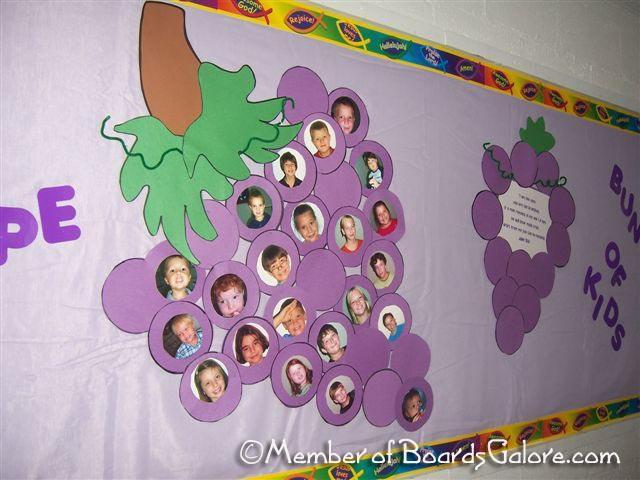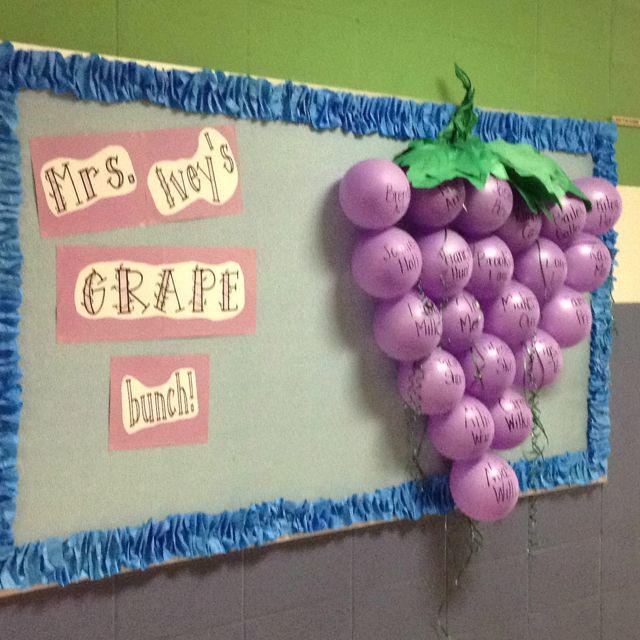The first image is the image on the left, the second image is the image on the right. Examine the images to the left and right. Is the description "The right image shows purple balloons used to represent grapes in a cluster, and the left image shows childrens' faces in the center of purple circles." accurate? Answer yes or no. Yes. The first image is the image on the left, the second image is the image on the right. For the images shown, is this caption "Balloons hang from a poster in the image on the right." true? Answer yes or no. Yes. 